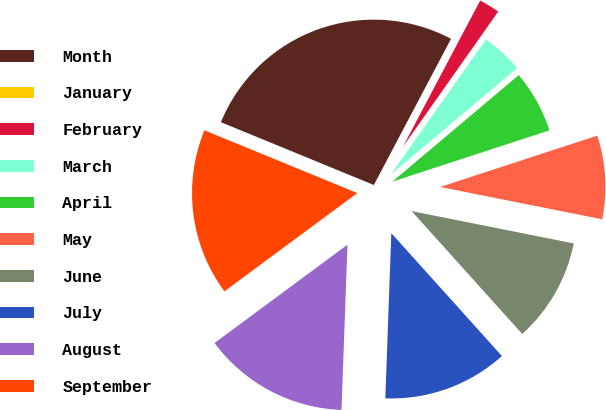Convert chart to OTSL. <chart><loc_0><loc_0><loc_500><loc_500><pie_chart><fcel>Month<fcel>January<fcel>February<fcel>March<fcel>April<fcel>May<fcel>June<fcel>July<fcel>August<fcel>September<nl><fcel>26.53%<fcel>0.0%<fcel>2.04%<fcel>4.08%<fcel>6.12%<fcel>8.16%<fcel>10.2%<fcel>12.24%<fcel>14.29%<fcel>16.33%<nl></chart> 